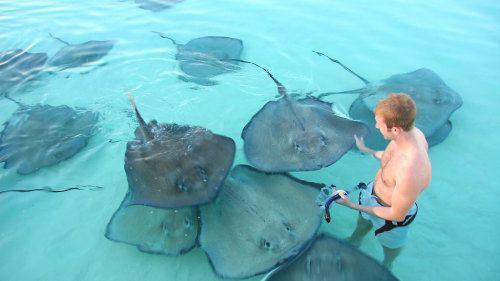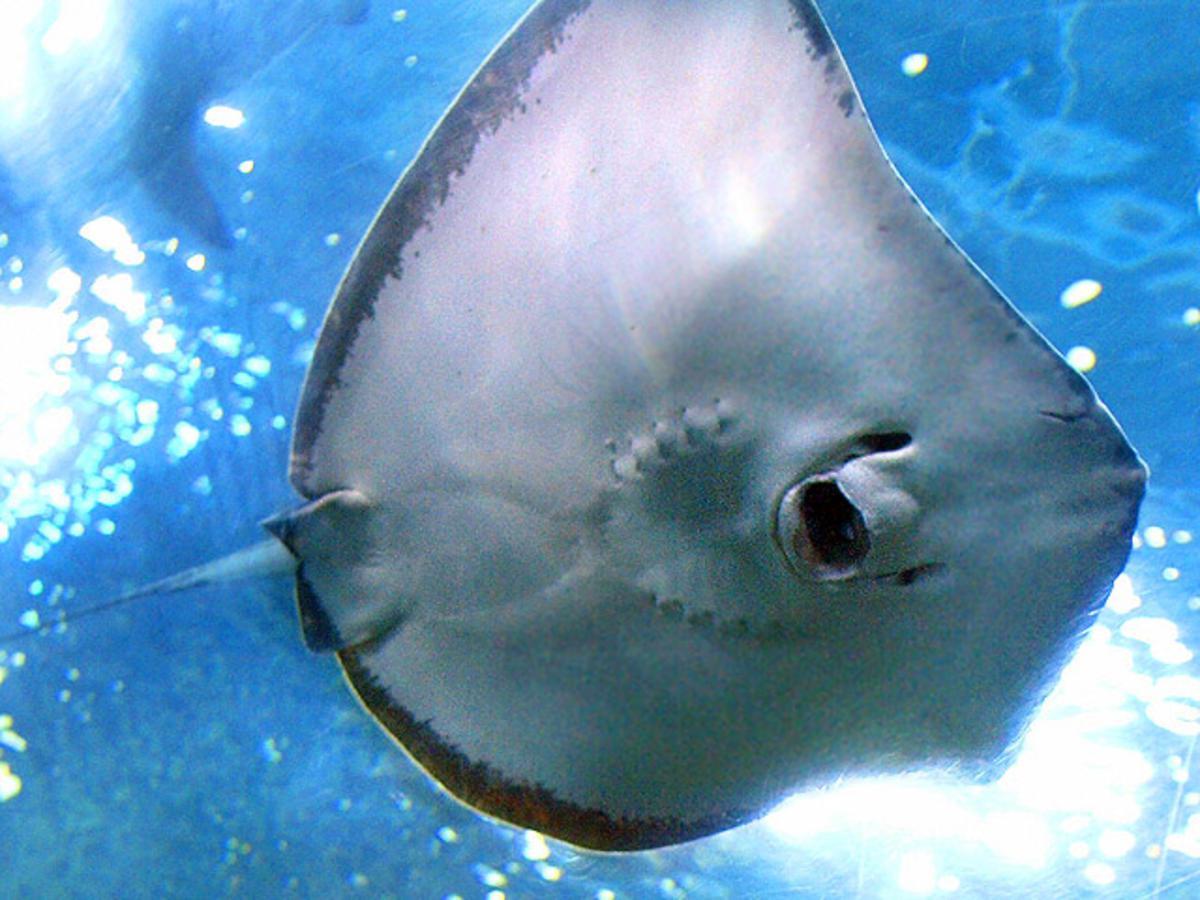The first image is the image on the left, the second image is the image on the right. For the images displayed, is the sentence "No image contains more than two stingray, and one image shows the underside of at least one stingray, while the other image shows the top of at least one stingray." factually correct? Answer yes or no. No. The first image is the image on the left, the second image is the image on the right. Considering the images on both sides, is "The left and right image contains no more than three stingrays." valid? Answer yes or no. No. 